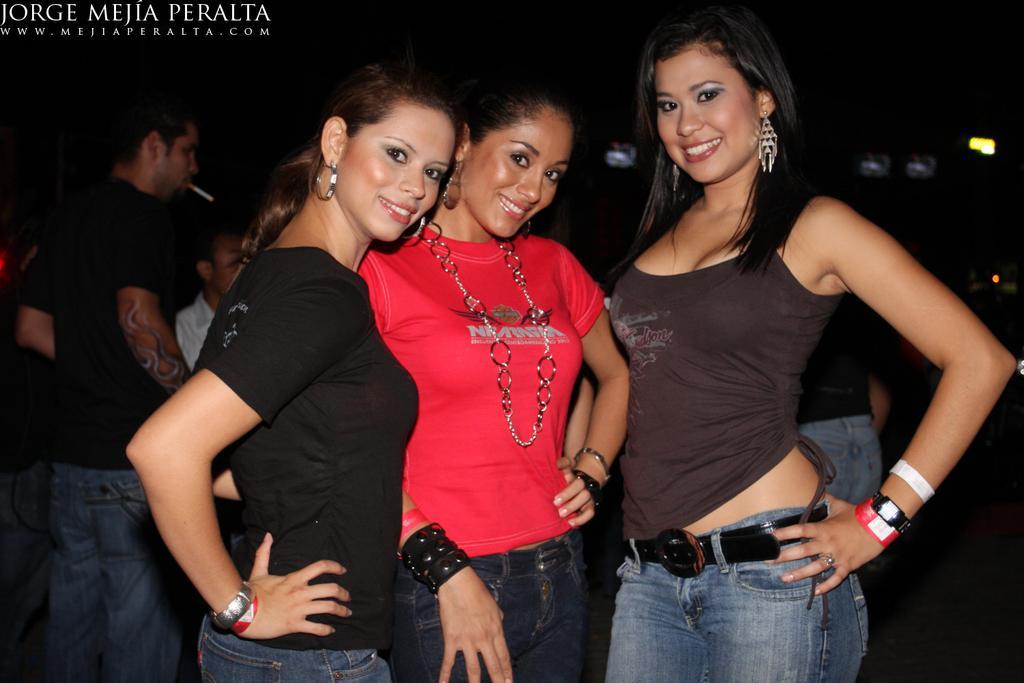Describe this image in one or two sentences. In this image we can see some group of persons standing, in the foreground of the image there are some persons standing together and posing for a photograph and in the background of the image there is a person wearing black color T-shirt holding cigarette in his hands. 